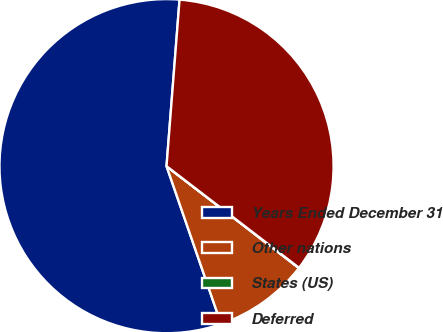Convert chart to OTSL. <chart><loc_0><loc_0><loc_500><loc_500><pie_chart><fcel>Years Ended December 31<fcel>Other nations<fcel>States (US)<fcel>Deferred<nl><fcel>56.54%<fcel>9.26%<fcel>0.03%<fcel>34.17%<nl></chart> 